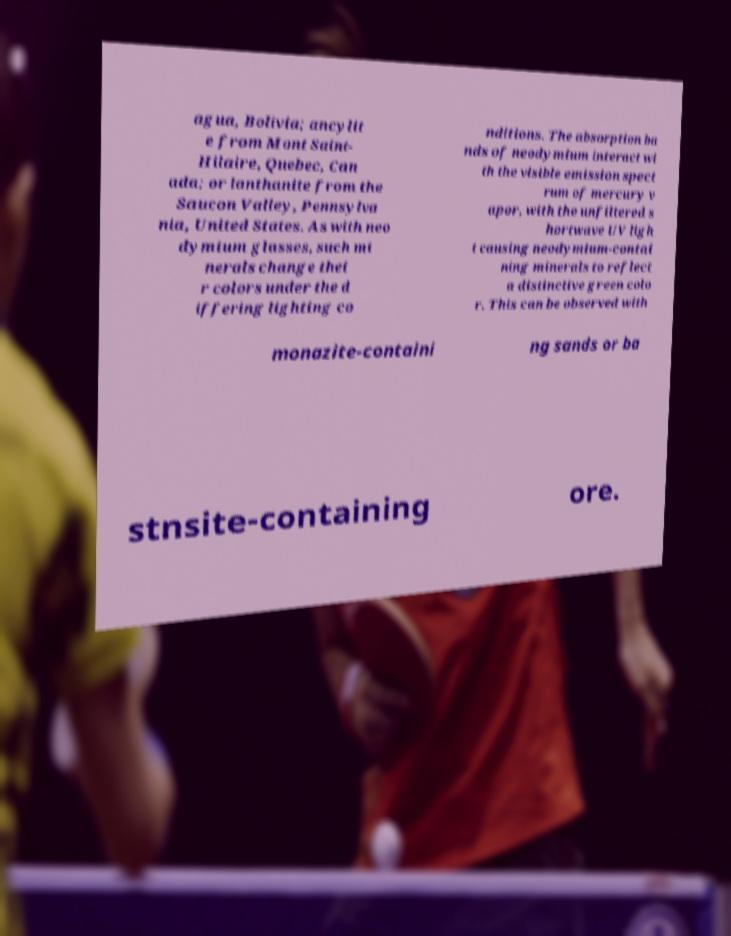Could you extract and type out the text from this image? agua, Bolivia; ancylit e from Mont Saint- Hilaire, Quebec, Can ada; or lanthanite from the Saucon Valley, Pennsylva nia, United States. As with neo dymium glasses, such mi nerals change thei r colors under the d iffering lighting co nditions. The absorption ba nds of neodymium interact wi th the visible emission spect rum of mercury v apor, with the unfiltered s hortwave UV ligh t causing neodymium-contai ning minerals to reflect a distinctive green colo r. This can be observed with monazite-containi ng sands or ba stnsite-containing ore. 